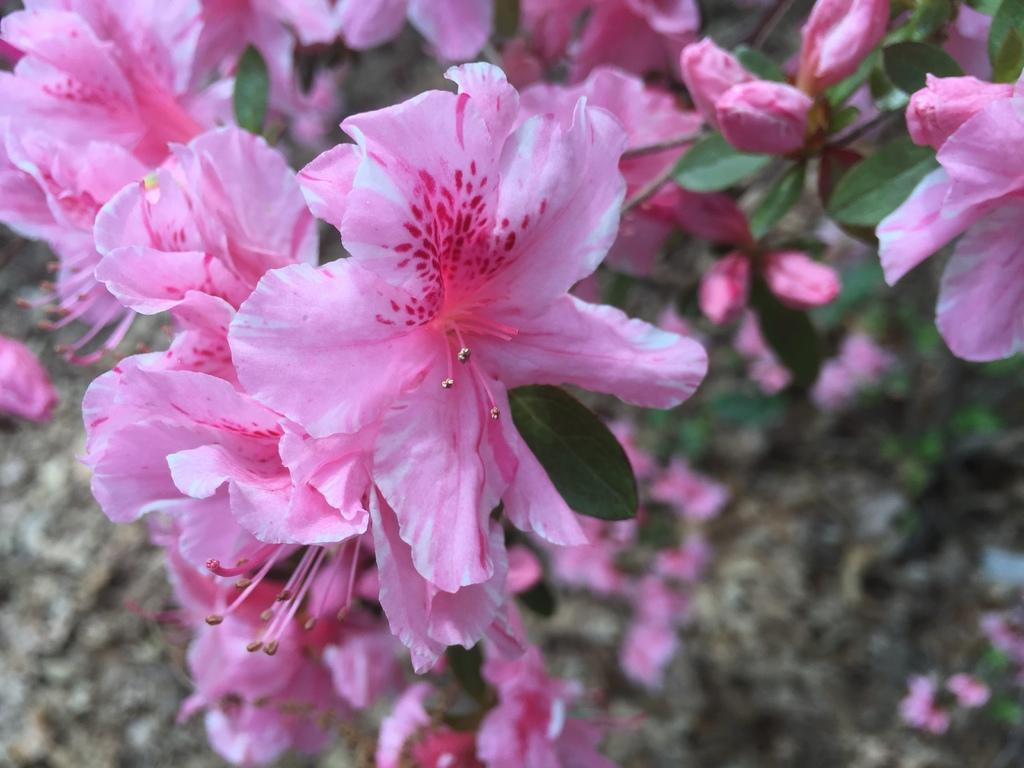What type of plant elements can be seen in the image? There are flowers, leaves, and stems in the image. Can you describe the background of the image? The background of the image is blurred. What type of organization is responsible for the crib in the image? There is no crib present in the image, so it is not possible to determine which organization might be responsible for it. 